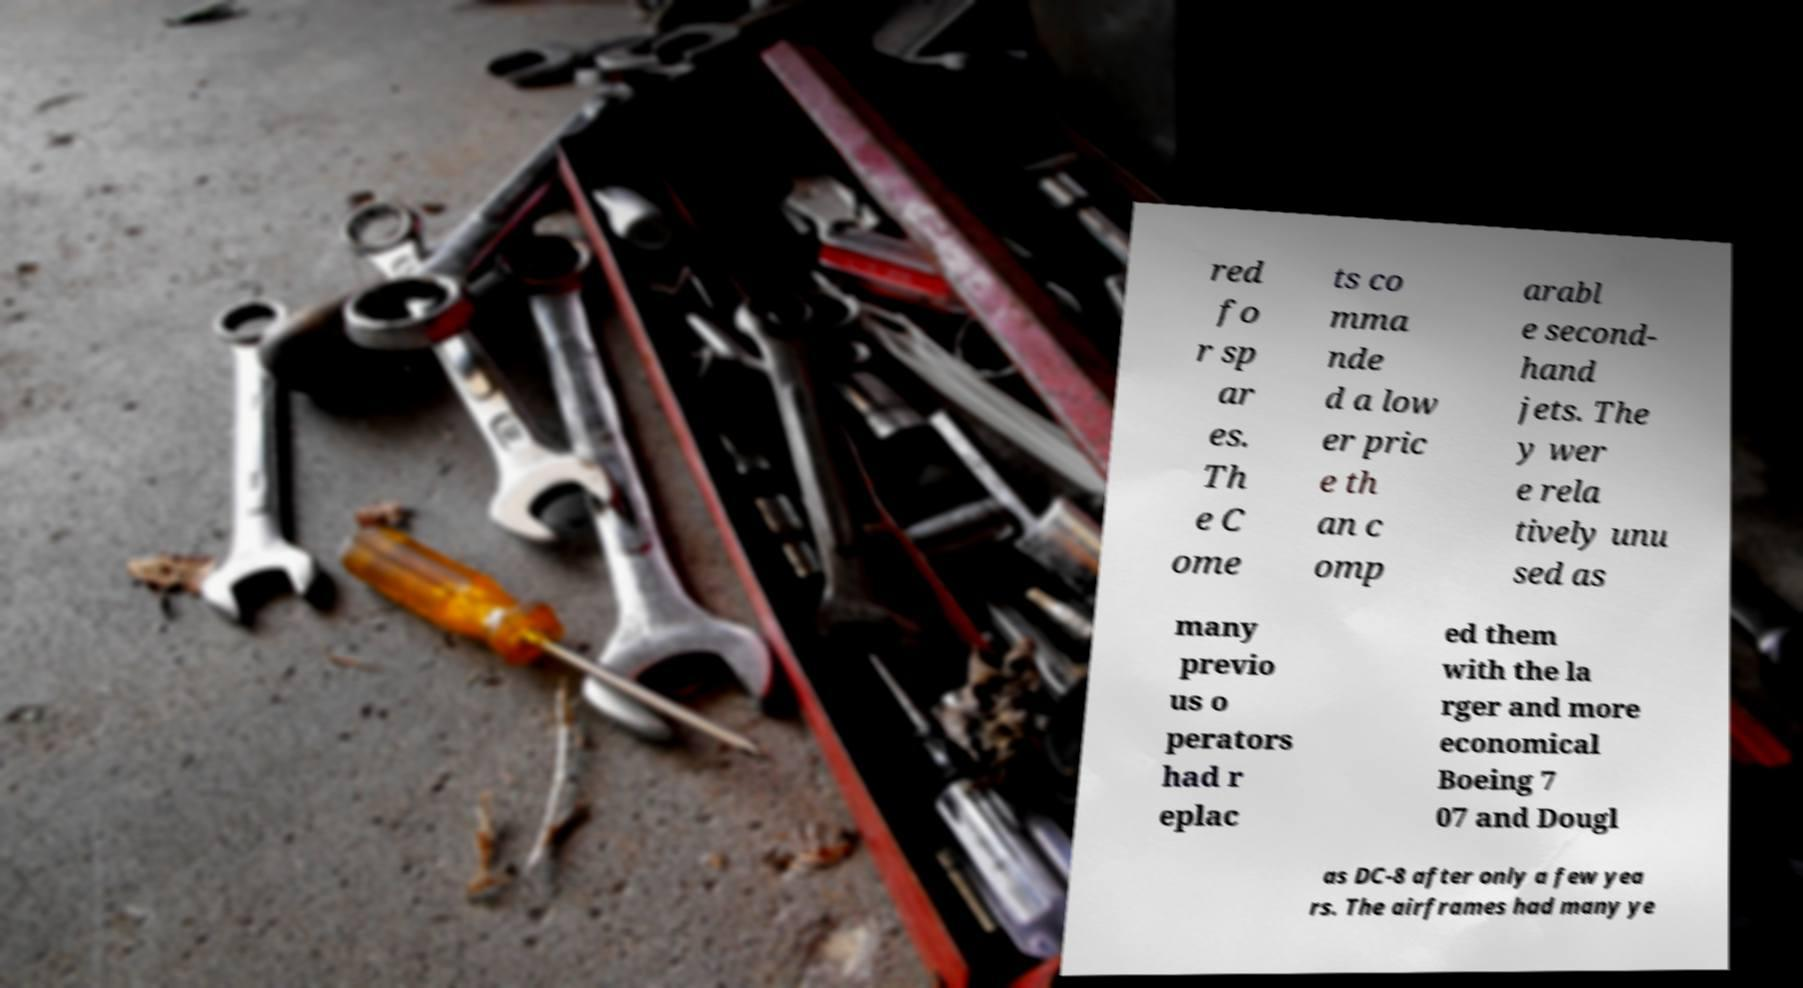For documentation purposes, I need the text within this image transcribed. Could you provide that? red fo r sp ar es. Th e C ome ts co mma nde d a low er pric e th an c omp arabl e second- hand jets. The y wer e rela tively unu sed as many previo us o perators had r eplac ed them with the la rger and more economical Boeing 7 07 and Dougl as DC-8 after only a few yea rs. The airframes had many ye 